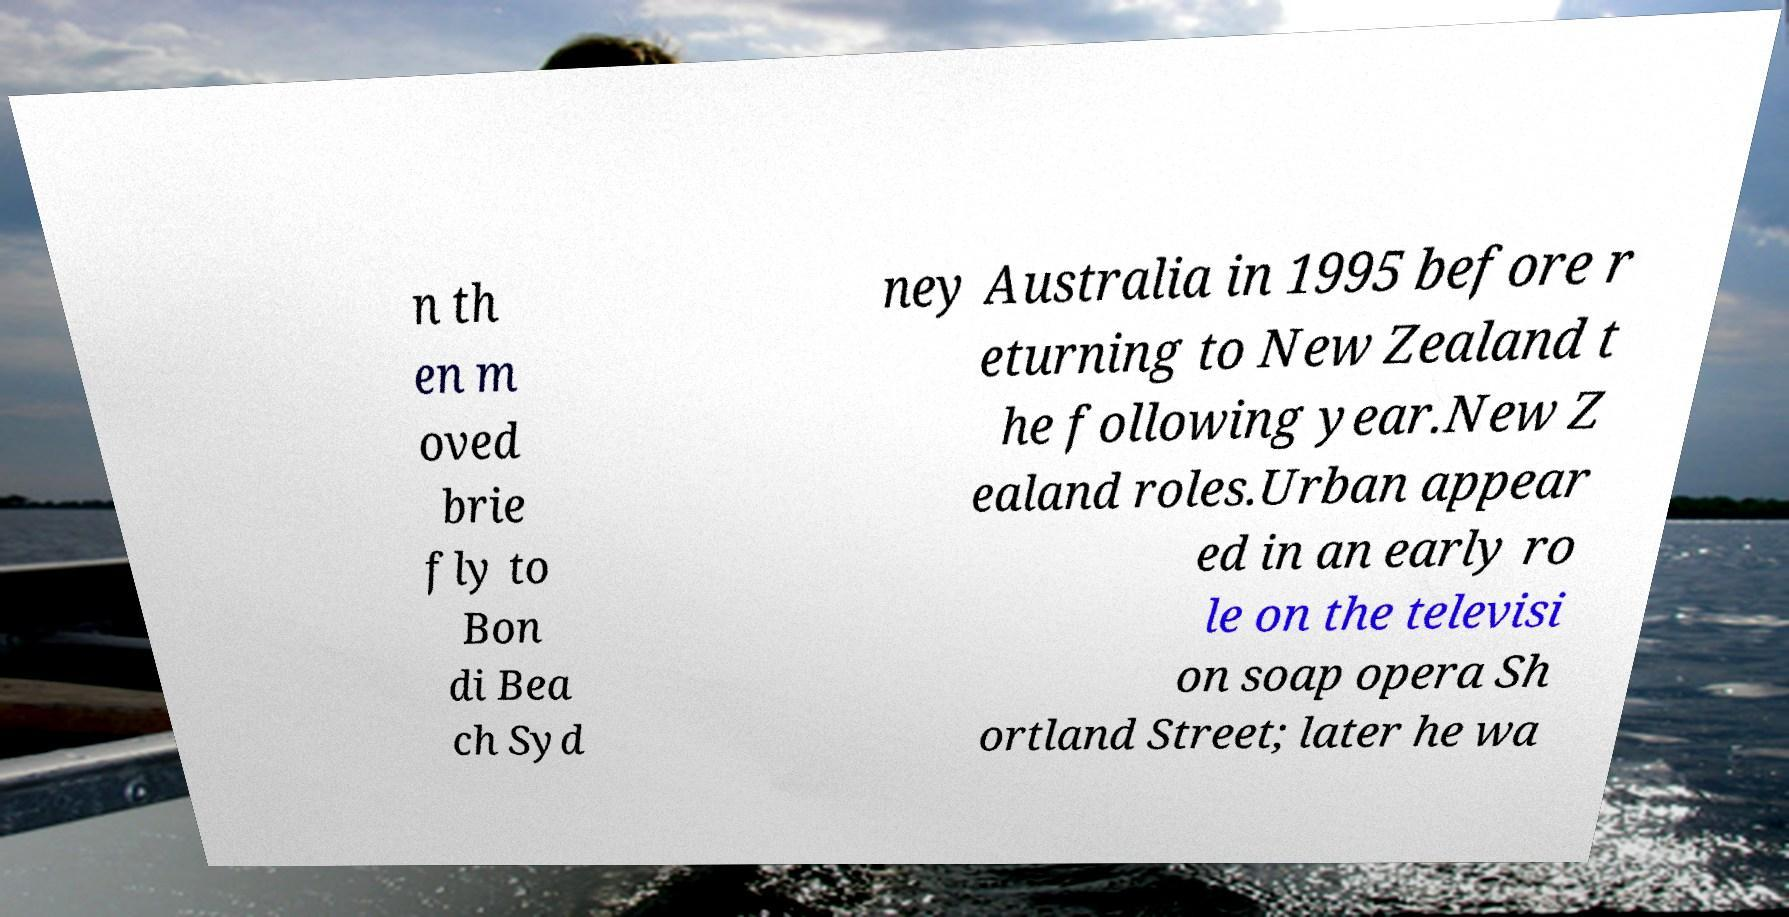Could you extract and type out the text from this image? n th en m oved brie fly to Bon di Bea ch Syd ney Australia in 1995 before r eturning to New Zealand t he following year.New Z ealand roles.Urban appear ed in an early ro le on the televisi on soap opera Sh ortland Street; later he wa 